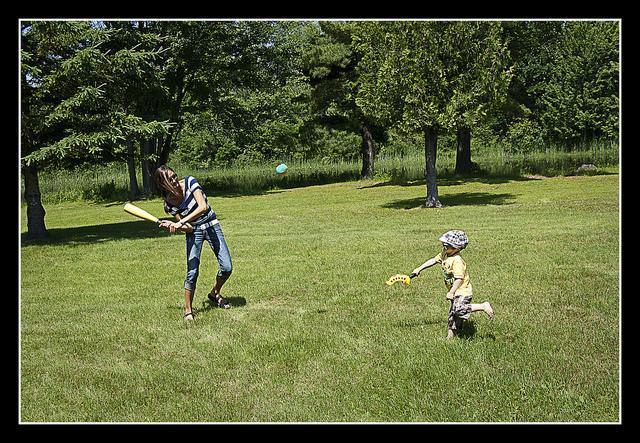How many people are there?
Give a very brief answer. 2. How many of the train cars can you see someone sticking their head out of?
Give a very brief answer. 0. 